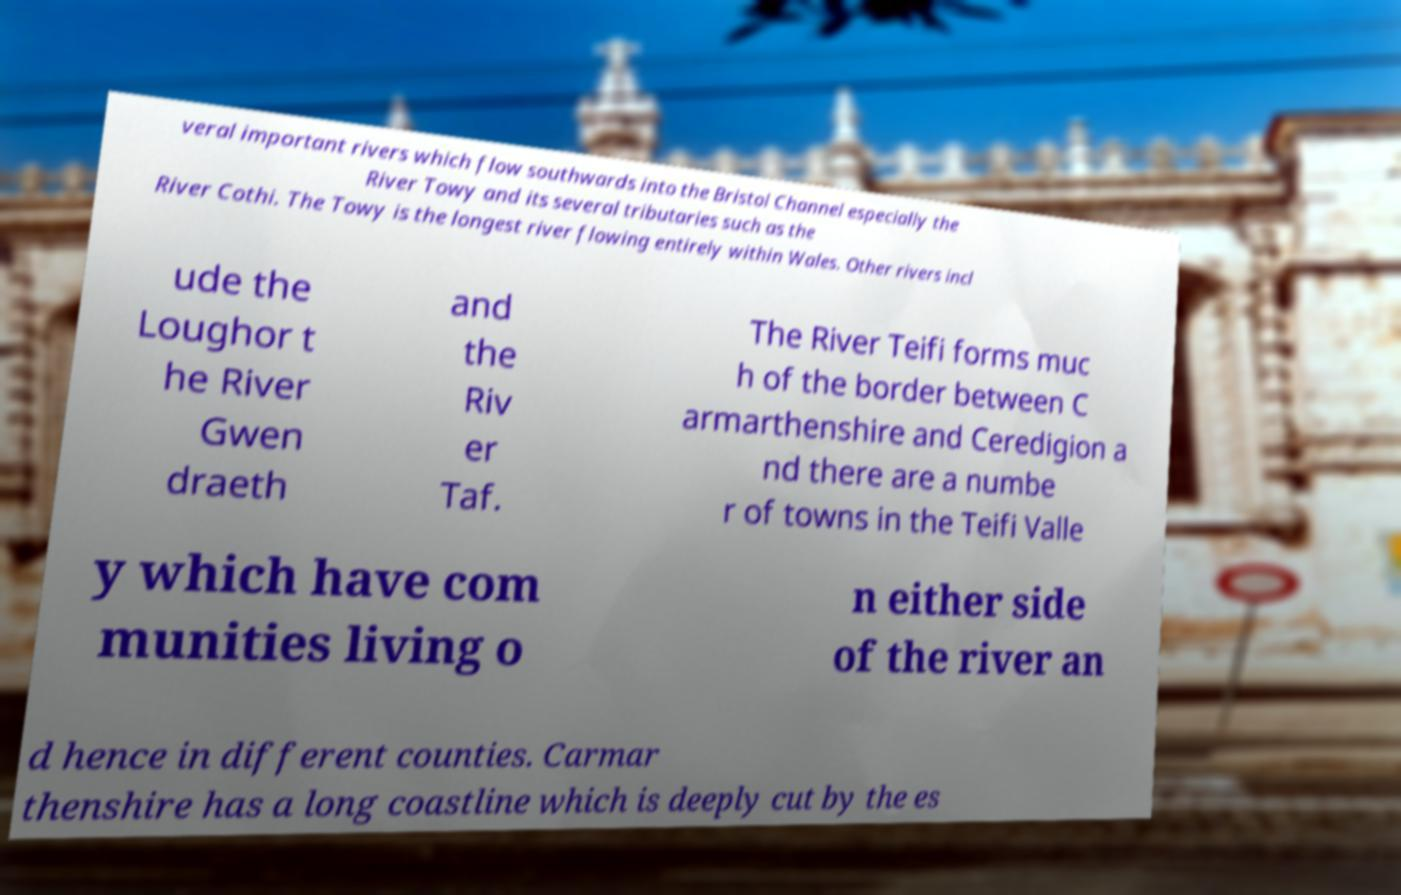I need the written content from this picture converted into text. Can you do that? veral important rivers which flow southwards into the Bristol Channel especially the River Towy and its several tributaries such as the River Cothi. The Towy is the longest river flowing entirely within Wales. Other rivers incl ude the Loughor t he River Gwen draeth and the Riv er Taf. The River Teifi forms muc h of the border between C armarthenshire and Ceredigion a nd there are a numbe r of towns in the Teifi Valle y which have com munities living o n either side of the river an d hence in different counties. Carmar thenshire has a long coastline which is deeply cut by the es 